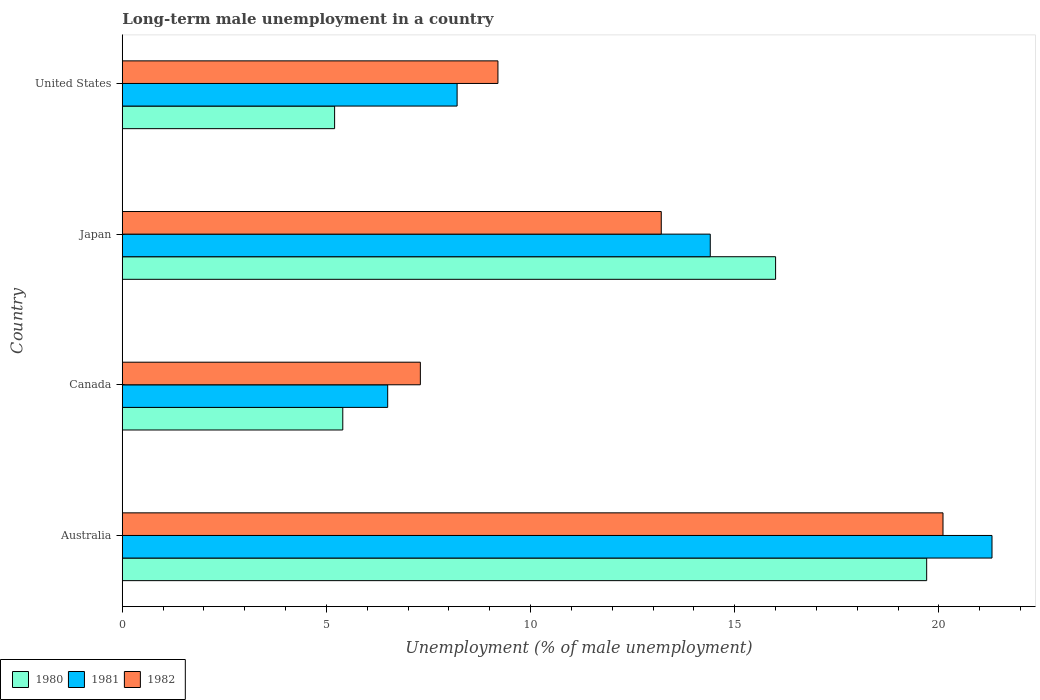How many different coloured bars are there?
Provide a short and direct response. 3. Are the number of bars per tick equal to the number of legend labels?
Your response must be concise. Yes. Are the number of bars on each tick of the Y-axis equal?
Make the answer very short. Yes. How many bars are there on the 2nd tick from the top?
Keep it short and to the point. 3. In how many cases, is the number of bars for a given country not equal to the number of legend labels?
Make the answer very short. 0. What is the percentage of long-term unemployed male population in 1981 in Australia?
Your response must be concise. 21.3. Across all countries, what is the maximum percentage of long-term unemployed male population in 1982?
Offer a very short reply. 20.1. Across all countries, what is the minimum percentage of long-term unemployed male population in 1981?
Your answer should be very brief. 6.5. In which country was the percentage of long-term unemployed male population in 1980 maximum?
Provide a succinct answer. Australia. In which country was the percentage of long-term unemployed male population in 1981 minimum?
Give a very brief answer. Canada. What is the total percentage of long-term unemployed male population in 1980 in the graph?
Provide a short and direct response. 46.3. What is the difference between the percentage of long-term unemployed male population in 1981 in Canada and that in United States?
Your answer should be very brief. -1.7. What is the difference between the percentage of long-term unemployed male population in 1981 in United States and the percentage of long-term unemployed male population in 1980 in Australia?
Keep it short and to the point. -11.5. What is the average percentage of long-term unemployed male population in 1982 per country?
Offer a very short reply. 12.45. What is the difference between the percentage of long-term unemployed male population in 1982 and percentage of long-term unemployed male population in 1981 in Canada?
Make the answer very short. 0.8. In how many countries, is the percentage of long-term unemployed male population in 1980 greater than 7 %?
Your answer should be compact. 2. What is the ratio of the percentage of long-term unemployed male population in 1980 in Australia to that in Canada?
Give a very brief answer. 3.65. Is the percentage of long-term unemployed male population in 1980 in Australia less than that in Canada?
Give a very brief answer. No. Is the difference between the percentage of long-term unemployed male population in 1982 in Japan and United States greater than the difference between the percentage of long-term unemployed male population in 1981 in Japan and United States?
Your response must be concise. No. What is the difference between the highest and the second highest percentage of long-term unemployed male population in 1981?
Keep it short and to the point. 6.9. What is the difference between the highest and the lowest percentage of long-term unemployed male population in 1981?
Offer a very short reply. 14.8. In how many countries, is the percentage of long-term unemployed male population in 1980 greater than the average percentage of long-term unemployed male population in 1980 taken over all countries?
Your answer should be very brief. 2. How many bars are there?
Your answer should be very brief. 12. How many countries are there in the graph?
Ensure brevity in your answer.  4. What is the difference between two consecutive major ticks on the X-axis?
Your answer should be very brief. 5. Are the values on the major ticks of X-axis written in scientific E-notation?
Offer a terse response. No. Does the graph contain any zero values?
Ensure brevity in your answer.  No. Does the graph contain grids?
Provide a succinct answer. No. Where does the legend appear in the graph?
Give a very brief answer. Bottom left. What is the title of the graph?
Offer a very short reply. Long-term male unemployment in a country. What is the label or title of the X-axis?
Offer a terse response. Unemployment (% of male unemployment). What is the Unemployment (% of male unemployment) of 1980 in Australia?
Offer a very short reply. 19.7. What is the Unemployment (% of male unemployment) of 1981 in Australia?
Your response must be concise. 21.3. What is the Unemployment (% of male unemployment) of 1982 in Australia?
Make the answer very short. 20.1. What is the Unemployment (% of male unemployment) of 1980 in Canada?
Your answer should be very brief. 5.4. What is the Unemployment (% of male unemployment) of 1982 in Canada?
Offer a terse response. 7.3. What is the Unemployment (% of male unemployment) of 1980 in Japan?
Ensure brevity in your answer.  16. What is the Unemployment (% of male unemployment) of 1981 in Japan?
Offer a terse response. 14.4. What is the Unemployment (% of male unemployment) in 1982 in Japan?
Offer a very short reply. 13.2. What is the Unemployment (% of male unemployment) in 1980 in United States?
Your answer should be compact. 5.2. What is the Unemployment (% of male unemployment) of 1981 in United States?
Give a very brief answer. 8.2. What is the Unemployment (% of male unemployment) of 1982 in United States?
Offer a terse response. 9.2. Across all countries, what is the maximum Unemployment (% of male unemployment) of 1980?
Offer a terse response. 19.7. Across all countries, what is the maximum Unemployment (% of male unemployment) in 1981?
Offer a very short reply. 21.3. Across all countries, what is the maximum Unemployment (% of male unemployment) in 1982?
Offer a terse response. 20.1. Across all countries, what is the minimum Unemployment (% of male unemployment) of 1980?
Your answer should be compact. 5.2. Across all countries, what is the minimum Unemployment (% of male unemployment) of 1982?
Make the answer very short. 7.3. What is the total Unemployment (% of male unemployment) in 1980 in the graph?
Your answer should be very brief. 46.3. What is the total Unemployment (% of male unemployment) of 1981 in the graph?
Your response must be concise. 50.4. What is the total Unemployment (% of male unemployment) of 1982 in the graph?
Give a very brief answer. 49.8. What is the difference between the Unemployment (% of male unemployment) in 1980 in Australia and that in Canada?
Keep it short and to the point. 14.3. What is the difference between the Unemployment (% of male unemployment) of 1981 in Australia and that in Canada?
Provide a succinct answer. 14.8. What is the difference between the Unemployment (% of male unemployment) in 1981 in Australia and that in United States?
Keep it short and to the point. 13.1. What is the difference between the Unemployment (% of male unemployment) of 1982 in Australia and that in United States?
Make the answer very short. 10.9. What is the difference between the Unemployment (% of male unemployment) of 1981 in Canada and that in Japan?
Your response must be concise. -7.9. What is the difference between the Unemployment (% of male unemployment) of 1981 in Canada and that in United States?
Make the answer very short. -1.7. What is the difference between the Unemployment (% of male unemployment) of 1982 in Canada and that in United States?
Offer a terse response. -1.9. What is the difference between the Unemployment (% of male unemployment) of 1981 in Japan and that in United States?
Your answer should be very brief. 6.2. What is the difference between the Unemployment (% of male unemployment) of 1982 in Japan and that in United States?
Give a very brief answer. 4. What is the difference between the Unemployment (% of male unemployment) in 1980 in Australia and the Unemployment (% of male unemployment) in 1981 in Canada?
Your answer should be very brief. 13.2. What is the difference between the Unemployment (% of male unemployment) of 1980 in Australia and the Unemployment (% of male unemployment) of 1982 in Canada?
Make the answer very short. 12.4. What is the difference between the Unemployment (% of male unemployment) of 1980 in Australia and the Unemployment (% of male unemployment) of 1981 in Japan?
Offer a terse response. 5.3. What is the difference between the Unemployment (% of male unemployment) of 1981 in Australia and the Unemployment (% of male unemployment) of 1982 in Japan?
Offer a terse response. 8.1. What is the difference between the Unemployment (% of male unemployment) in 1980 in Australia and the Unemployment (% of male unemployment) in 1982 in United States?
Ensure brevity in your answer.  10.5. What is the difference between the Unemployment (% of male unemployment) in 1980 in Canada and the Unemployment (% of male unemployment) in 1981 in Japan?
Your answer should be compact. -9. What is the difference between the Unemployment (% of male unemployment) in 1980 in Canada and the Unemployment (% of male unemployment) in 1982 in Japan?
Your response must be concise. -7.8. What is the difference between the Unemployment (% of male unemployment) in 1981 in Canada and the Unemployment (% of male unemployment) in 1982 in Japan?
Keep it short and to the point. -6.7. What is the difference between the Unemployment (% of male unemployment) of 1980 in Canada and the Unemployment (% of male unemployment) of 1981 in United States?
Keep it short and to the point. -2.8. What is the difference between the Unemployment (% of male unemployment) in 1980 in Canada and the Unemployment (% of male unemployment) in 1982 in United States?
Your answer should be very brief. -3.8. What is the difference between the Unemployment (% of male unemployment) in 1981 in Canada and the Unemployment (% of male unemployment) in 1982 in United States?
Give a very brief answer. -2.7. What is the difference between the Unemployment (% of male unemployment) of 1980 in Japan and the Unemployment (% of male unemployment) of 1981 in United States?
Provide a short and direct response. 7.8. What is the difference between the Unemployment (% of male unemployment) of 1981 in Japan and the Unemployment (% of male unemployment) of 1982 in United States?
Your answer should be very brief. 5.2. What is the average Unemployment (% of male unemployment) of 1980 per country?
Provide a short and direct response. 11.57. What is the average Unemployment (% of male unemployment) of 1982 per country?
Give a very brief answer. 12.45. What is the difference between the Unemployment (% of male unemployment) of 1980 and Unemployment (% of male unemployment) of 1981 in Australia?
Offer a very short reply. -1.6. What is the difference between the Unemployment (% of male unemployment) of 1981 and Unemployment (% of male unemployment) of 1982 in Australia?
Your response must be concise. 1.2. What is the difference between the Unemployment (% of male unemployment) of 1981 and Unemployment (% of male unemployment) of 1982 in Canada?
Provide a succinct answer. -0.8. What is the difference between the Unemployment (% of male unemployment) of 1980 and Unemployment (% of male unemployment) of 1981 in United States?
Offer a terse response. -3. What is the difference between the Unemployment (% of male unemployment) in 1980 and Unemployment (% of male unemployment) in 1982 in United States?
Give a very brief answer. -4. What is the difference between the Unemployment (% of male unemployment) in 1981 and Unemployment (% of male unemployment) in 1982 in United States?
Ensure brevity in your answer.  -1. What is the ratio of the Unemployment (% of male unemployment) in 1980 in Australia to that in Canada?
Provide a short and direct response. 3.65. What is the ratio of the Unemployment (% of male unemployment) in 1981 in Australia to that in Canada?
Provide a succinct answer. 3.28. What is the ratio of the Unemployment (% of male unemployment) in 1982 in Australia to that in Canada?
Give a very brief answer. 2.75. What is the ratio of the Unemployment (% of male unemployment) of 1980 in Australia to that in Japan?
Ensure brevity in your answer.  1.23. What is the ratio of the Unemployment (% of male unemployment) of 1981 in Australia to that in Japan?
Your response must be concise. 1.48. What is the ratio of the Unemployment (% of male unemployment) of 1982 in Australia to that in Japan?
Offer a very short reply. 1.52. What is the ratio of the Unemployment (% of male unemployment) in 1980 in Australia to that in United States?
Give a very brief answer. 3.79. What is the ratio of the Unemployment (% of male unemployment) in 1981 in Australia to that in United States?
Provide a succinct answer. 2.6. What is the ratio of the Unemployment (% of male unemployment) of 1982 in Australia to that in United States?
Keep it short and to the point. 2.18. What is the ratio of the Unemployment (% of male unemployment) of 1980 in Canada to that in Japan?
Offer a terse response. 0.34. What is the ratio of the Unemployment (% of male unemployment) in 1981 in Canada to that in Japan?
Provide a succinct answer. 0.45. What is the ratio of the Unemployment (% of male unemployment) of 1982 in Canada to that in Japan?
Give a very brief answer. 0.55. What is the ratio of the Unemployment (% of male unemployment) in 1981 in Canada to that in United States?
Give a very brief answer. 0.79. What is the ratio of the Unemployment (% of male unemployment) in 1982 in Canada to that in United States?
Offer a very short reply. 0.79. What is the ratio of the Unemployment (% of male unemployment) in 1980 in Japan to that in United States?
Your answer should be compact. 3.08. What is the ratio of the Unemployment (% of male unemployment) in 1981 in Japan to that in United States?
Your answer should be very brief. 1.76. What is the ratio of the Unemployment (% of male unemployment) in 1982 in Japan to that in United States?
Keep it short and to the point. 1.43. What is the difference between the highest and the second highest Unemployment (% of male unemployment) in 1981?
Keep it short and to the point. 6.9. What is the difference between the highest and the second highest Unemployment (% of male unemployment) of 1982?
Your answer should be very brief. 6.9. What is the difference between the highest and the lowest Unemployment (% of male unemployment) in 1982?
Make the answer very short. 12.8. 